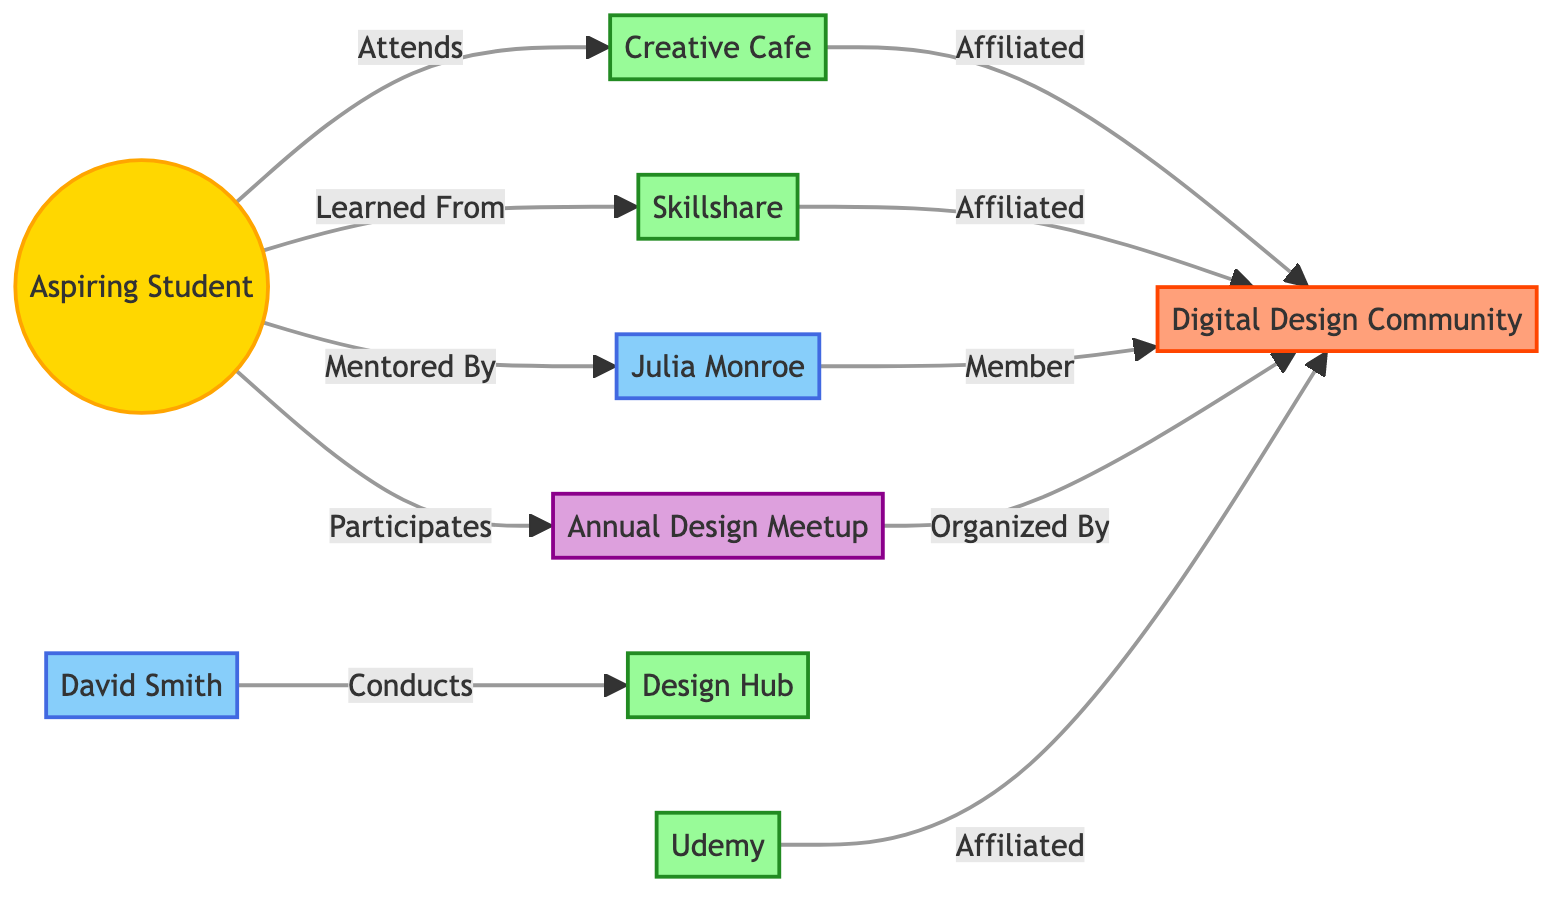What is the type of "Creative Cafe"? The "Creative Cafe" is categorized as a "Local Workshop" based on the node type specified in the diagram.
Answer: Local Workshop How many online workshops are shown in the diagram? The diagram contains two nodes classified as online workshops, namely "Skillshare" and "Udemy." Therefore, the count is two.
Answer: 2 Who conducts the "Design Hub" workshop? The "Design Hub" workshop is conducted by "David Smith," as indicated by the connection in the diagram where he is linked to the workshop as conducting it.
Answer: David Smith What type of relationship does the "Aspiring Student" have with the "Annual Design Meetup"? The "Aspiring Student" participates in the "Annual Design Meetup," which shows a direct relationship emphasized in the diagram.
Answer: Participates Which community center is affiliated with "Skillshare"? "Skillshare" is affiliated with the "Digital Design Community," as indicated by the direct connection pointing from "Skillshare" to the "community_center" node.
Answer: Digital Design Community How many mentors are present in the diagram? The diagram shows two mentors, "Julia Monroe" and "David Smith," who are both identified as mentor nodes. Thus, the count is two.
Answer: 2 What is the relationship between "Julia Monroe" and the "Digital Design Community"? "Julia Monroe" is a member of the "Digital Design Community," which is explicitly mentioned in the link connecting them in the diagram.
Answer: Member Which node does the "Annual Design Meetup" get organized by? The "Annual Design Meetup" is organized by the "Digital Design Community," as demonstrated by the relationship depicted between those two nodes in the diagram.
Answer: Digital Design Community What is the location of the "Creative Cafe"? The "Creative Cafe" is located in "Downtown," which is directly stated as part of the information related to that node.
Answer: Downtown 